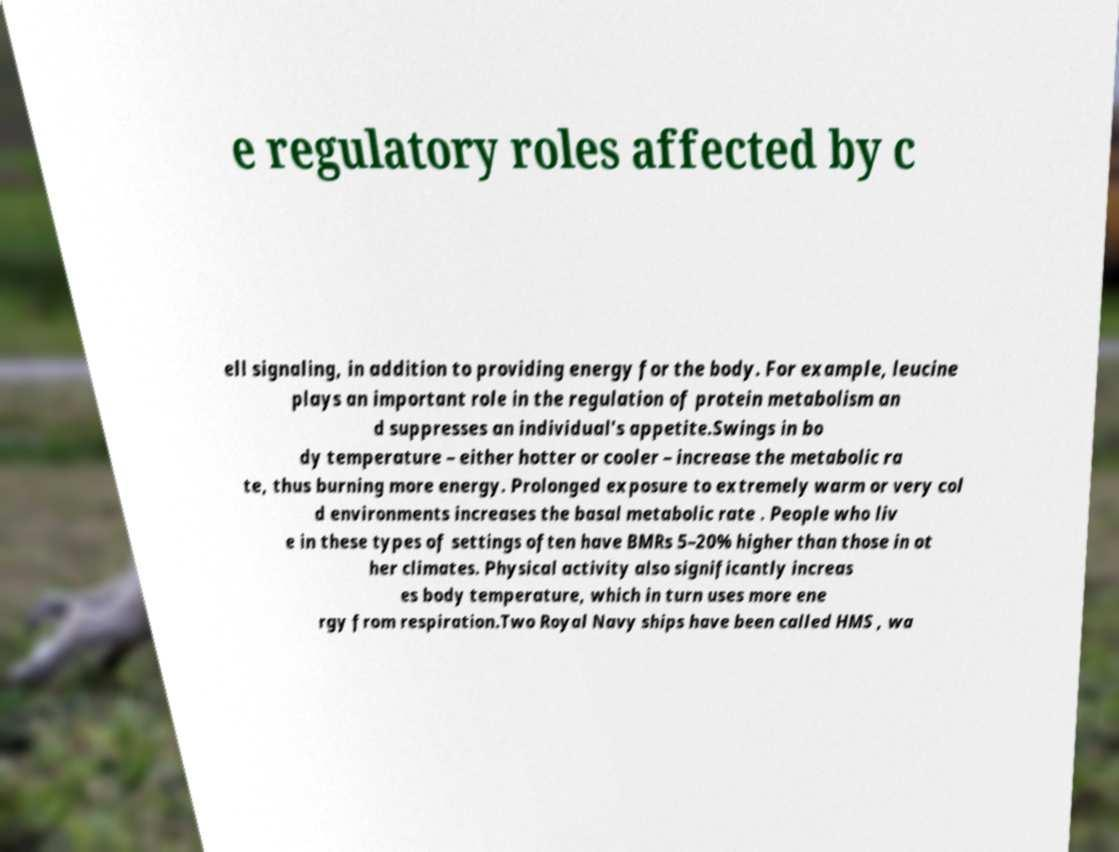Could you assist in decoding the text presented in this image and type it out clearly? e regulatory roles affected by c ell signaling, in addition to providing energy for the body. For example, leucine plays an important role in the regulation of protein metabolism an d suppresses an individual's appetite.Swings in bo dy temperature – either hotter or cooler – increase the metabolic ra te, thus burning more energy. Prolonged exposure to extremely warm or very col d environments increases the basal metabolic rate . People who liv e in these types of settings often have BMRs 5–20% higher than those in ot her climates. Physical activity also significantly increas es body temperature, which in turn uses more ene rgy from respiration.Two Royal Navy ships have been called HMS , wa 